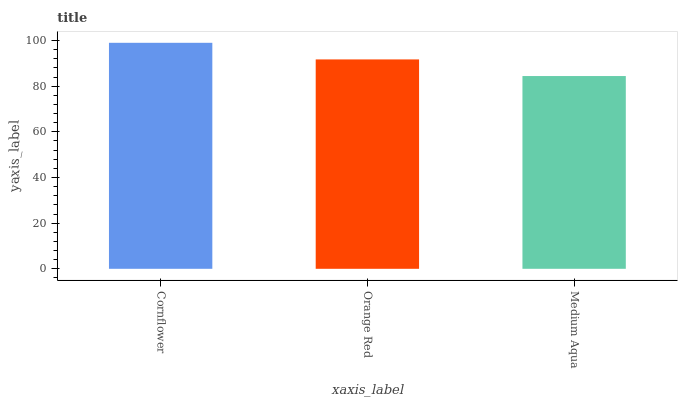Is Medium Aqua the minimum?
Answer yes or no. Yes. Is Cornflower the maximum?
Answer yes or no. Yes. Is Orange Red the minimum?
Answer yes or no. No. Is Orange Red the maximum?
Answer yes or no. No. Is Cornflower greater than Orange Red?
Answer yes or no. Yes. Is Orange Red less than Cornflower?
Answer yes or no. Yes. Is Orange Red greater than Cornflower?
Answer yes or no. No. Is Cornflower less than Orange Red?
Answer yes or no. No. Is Orange Red the high median?
Answer yes or no. Yes. Is Orange Red the low median?
Answer yes or no. Yes. Is Medium Aqua the high median?
Answer yes or no. No. Is Medium Aqua the low median?
Answer yes or no. No. 